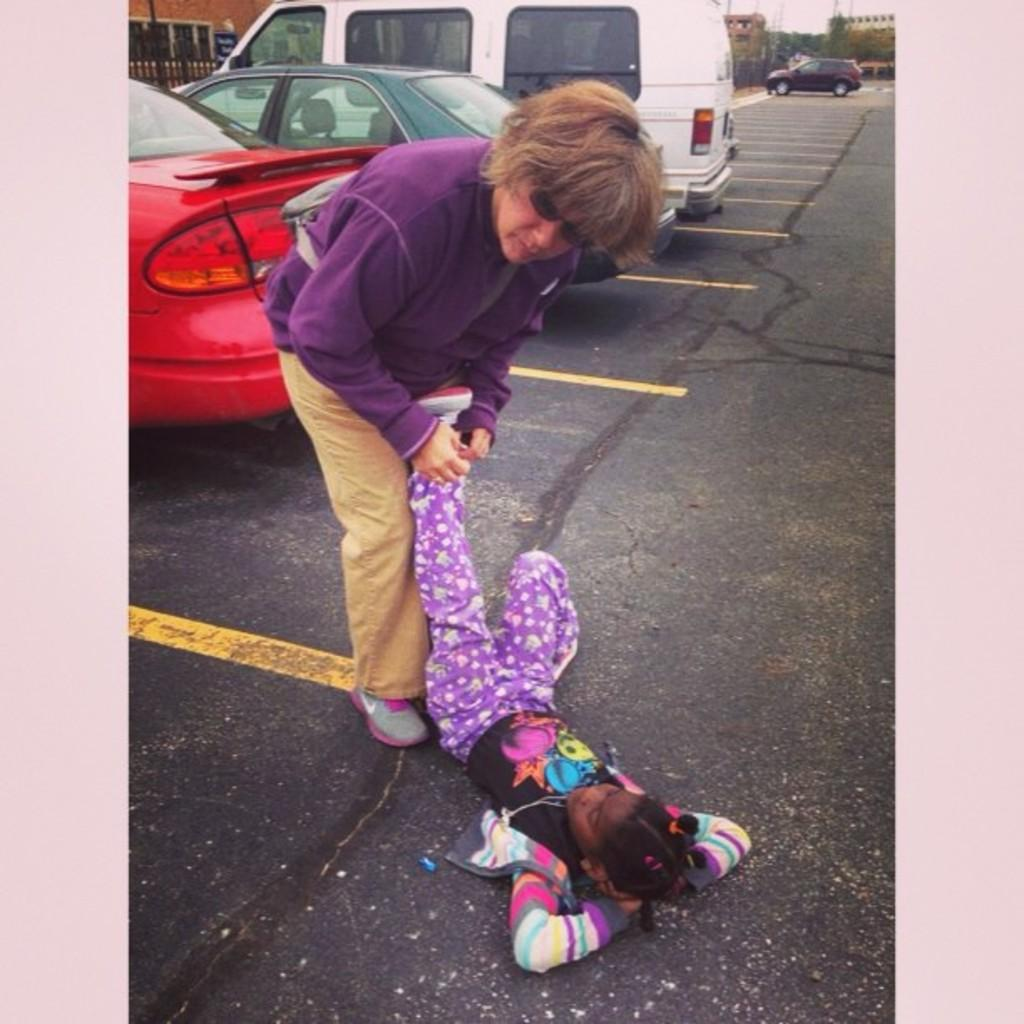What is the girl in the image doing? The girl is laying on the road and holding another girl's leg. What else can be seen on the road in the image? There are vehicles on the road. What is present in the image besides the girl and vehicles? There is a fence, a board, and buildings and trees in the background of the image. What can be seen in the sky in the image? The sky is visible in the background of the image. What type of rhythm can be heard coming from the girl's leg in the image? There is no rhythm present in the image, as it is a still photograph. 